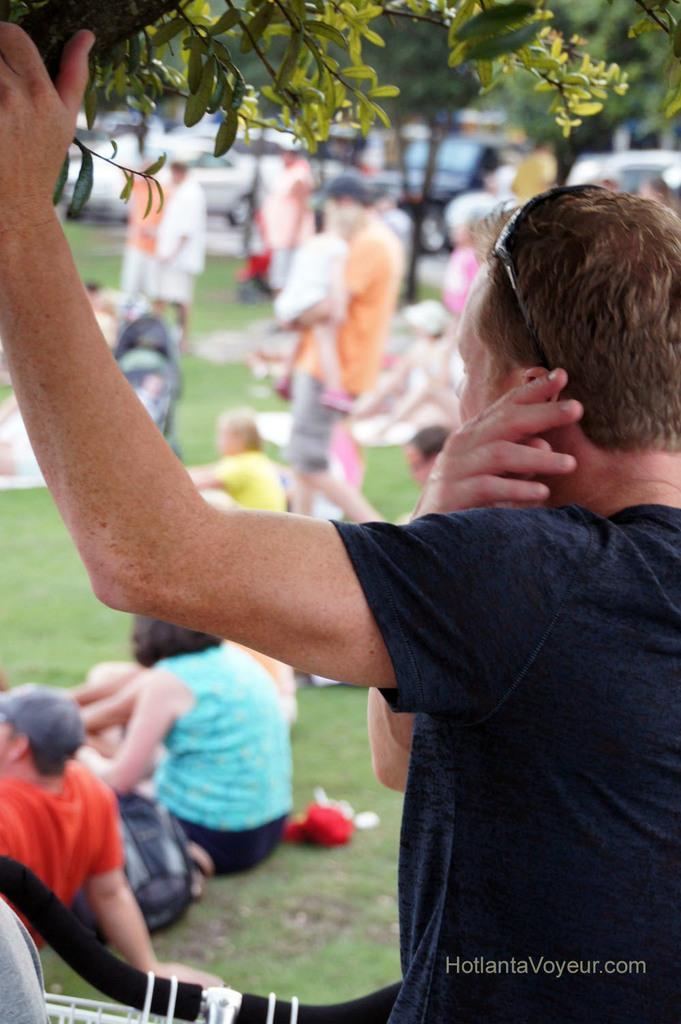Can you describe this image briefly? In this image there is a person holding a branch of the tree, and there are group of people standing and sitting on the grass, bicycle handle, vehicles. 